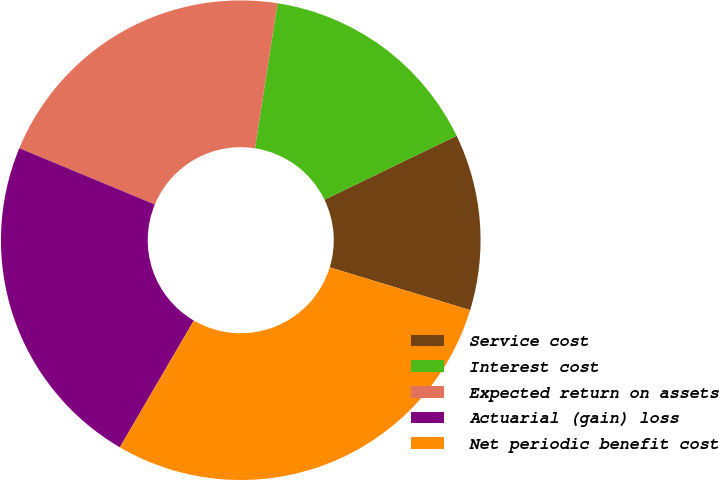Convert chart. <chart><loc_0><loc_0><loc_500><loc_500><pie_chart><fcel>Service cost<fcel>Interest cost<fcel>Expected return on assets<fcel>Actuarial (gain) loss<fcel>Net periodic benefit cost<nl><fcel>11.88%<fcel>15.38%<fcel>21.18%<fcel>22.86%<fcel>28.7%<nl></chart> 